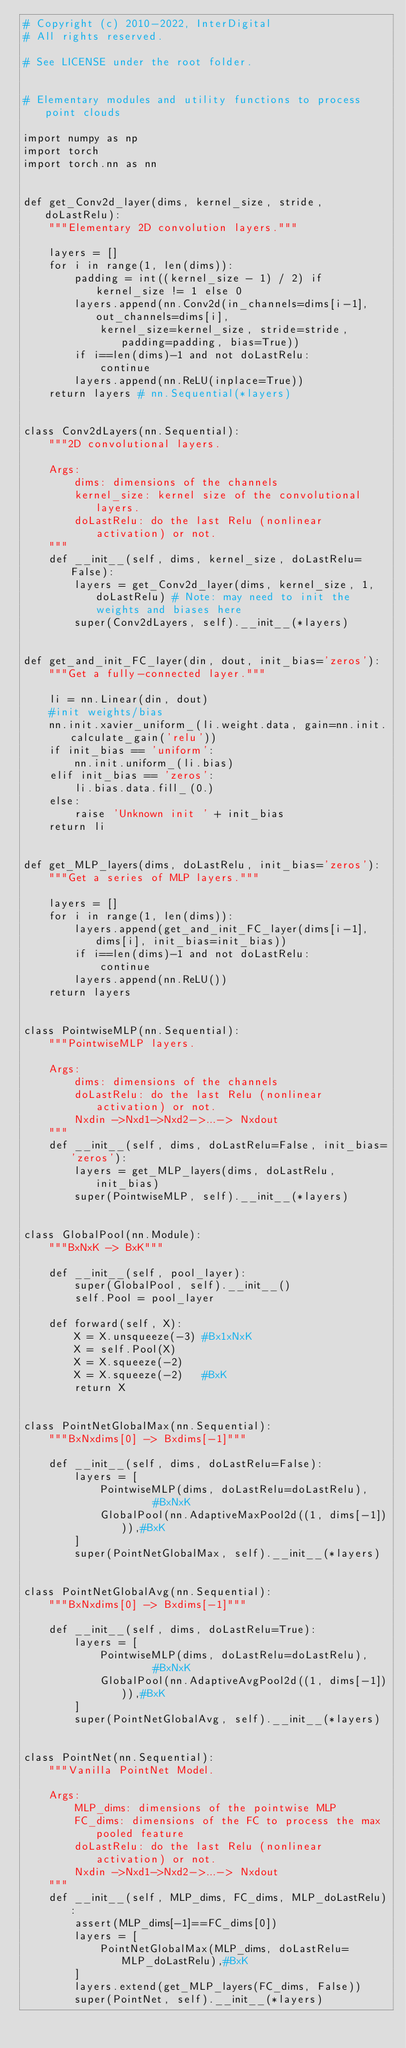<code> <loc_0><loc_0><loc_500><loc_500><_Python_># Copyright (c) 2010-2022, InterDigital
# All rights reserved. 

# See LICENSE under the root folder.


# Elementary modules and utility functions to process point clouds

import numpy as np
import torch
import torch.nn as nn


def get_Conv2d_layer(dims, kernel_size, stride, doLastRelu):
    """Elementary 2D convolution layers."""

    layers = []
    for i in range(1, len(dims)):
        padding = int((kernel_size - 1) / 2) if kernel_size != 1 else 0
        layers.append(nn.Conv2d(in_channels=dims[i-1], out_channels=dims[i],
            kernel_size=kernel_size, stride=stride, padding=padding, bias=True))
        if i==len(dims)-1 and not doLastRelu:
            continue
        layers.append(nn.ReLU(inplace=True))
    return layers # nn.Sequential(*layers)


class Conv2dLayers(nn.Sequential):
    """2D convolutional layers.

    Args:
        dims: dimensions of the channels
        kernel_size: kernel size of the convolutional layers.
        doLastRelu: do the last Relu (nonlinear activation) or not.
    """
    def __init__(self, dims, kernel_size, doLastRelu=False):
        layers = get_Conv2d_layer(dims, kernel_size, 1, doLastRelu) # Note: may need to init the weights and biases here
        super(Conv2dLayers, self).__init__(*layers)


def get_and_init_FC_layer(din, dout, init_bias='zeros'):
    """Get a fully-connected layer."""

    li = nn.Linear(din, dout)
    #init weights/bias
    nn.init.xavier_uniform_(li.weight.data, gain=nn.init.calculate_gain('relu'))
    if init_bias == 'uniform':
        nn.init.uniform_(li.bias)
    elif init_bias == 'zeros':
        li.bias.data.fill_(0.)
    else:
        raise 'Unknown init ' + init_bias
    return li


def get_MLP_layers(dims, doLastRelu, init_bias='zeros'):
    """Get a series of MLP layers."""

    layers = []
    for i in range(1, len(dims)):
        layers.append(get_and_init_FC_layer(dims[i-1], dims[i], init_bias=init_bias))
        if i==len(dims)-1 and not doLastRelu:
            continue
        layers.append(nn.ReLU())
    return layers


class PointwiseMLP(nn.Sequential):
    """PointwiseMLP layers.

    Args:
        dims: dimensions of the channels
        doLastRelu: do the last Relu (nonlinear activation) or not.
        Nxdin ->Nxd1->Nxd2->...-> Nxdout
    """
    def __init__(self, dims, doLastRelu=False, init_bias='zeros'):
        layers = get_MLP_layers(dims, doLastRelu, init_bias)
        super(PointwiseMLP, self).__init__(*layers)


class GlobalPool(nn.Module):
    """BxNxK -> BxK"""

    def __init__(self, pool_layer):
        super(GlobalPool, self).__init__()
        self.Pool = pool_layer

    def forward(self, X):
        X = X.unsqueeze(-3) #Bx1xNxK
        X = self.Pool(X)
        X = X.squeeze(-2)
        X = X.squeeze(-2)   #BxK
        return X


class PointNetGlobalMax(nn.Sequential):
    """BxNxdims[0] -> Bxdims[-1]"""

    def __init__(self, dims, doLastRelu=False):
        layers = [
            PointwiseMLP(dims, doLastRelu=doLastRelu),      #BxNxK
            GlobalPool(nn.AdaptiveMaxPool2d((1, dims[-1]))),#BxK
        ]
        super(PointNetGlobalMax, self).__init__(*layers)


class PointNetGlobalAvg(nn.Sequential):
    """BxNxdims[0] -> Bxdims[-1]"""

    def __init__(self, dims, doLastRelu=True):
        layers = [
            PointwiseMLP(dims, doLastRelu=doLastRelu),      #BxNxK
            GlobalPool(nn.AdaptiveAvgPool2d((1, dims[-1]))),#BxK
        ]
        super(PointNetGlobalAvg, self).__init__(*layers)


class PointNet(nn.Sequential):
    """Vanilla PointNet Model.

    Args:
        MLP_dims: dimensions of the pointwise MLP
        FC_dims: dimensions of the FC to process the max pooled feature
        doLastRelu: do the last Relu (nonlinear activation) or not.
        Nxdin ->Nxd1->Nxd2->...-> Nxdout
    """
    def __init__(self, MLP_dims, FC_dims, MLP_doLastRelu):
        assert(MLP_dims[-1]==FC_dims[0])
        layers = [
            PointNetGlobalMax(MLP_dims, doLastRelu=MLP_doLastRelu),#BxK
        ]
        layers.extend(get_MLP_layers(FC_dims, False))
        super(PointNet, self).__init__(*layers)</code> 